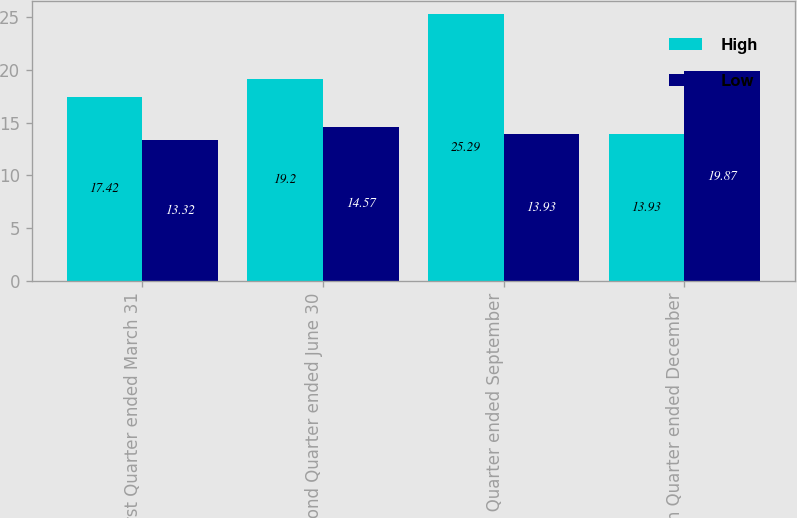<chart> <loc_0><loc_0><loc_500><loc_500><stacked_bar_chart><ecel><fcel>First Quarter ended March 31<fcel>Second Quarter ended June 30<fcel>Third Quarter ended September<fcel>Fourth Quarter ended December<nl><fcel>High<fcel>17.42<fcel>19.2<fcel>25.29<fcel>13.93<nl><fcel>Low<fcel>13.32<fcel>14.57<fcel>13.93<fcel>19.87<nl></chart> 